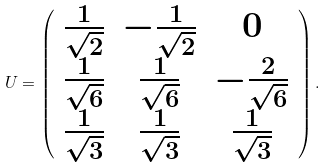Convert formula to latex. <formula><loc_0><loc_0><loc_500><loc_500>U = \left ( \begin{array} { c c c } \frac { 1 } { \sqrt { 2 } } & - \frac { 1 } { \sqrt { 2 } } & 0 \\ \frac { 1 } { \sqrt { 6 } } & \frac { 1 } { \sqrt { 6 } } & - \frac { 2 } { \sqrt { 6 } } \\ \frac { 1 } { \sqrt { 3 } } & \frac { 1 } { \sqrt { 3 } } & \frac { 1 } { \sqrt { 3 } } \end{array} \right ) .</formula> 